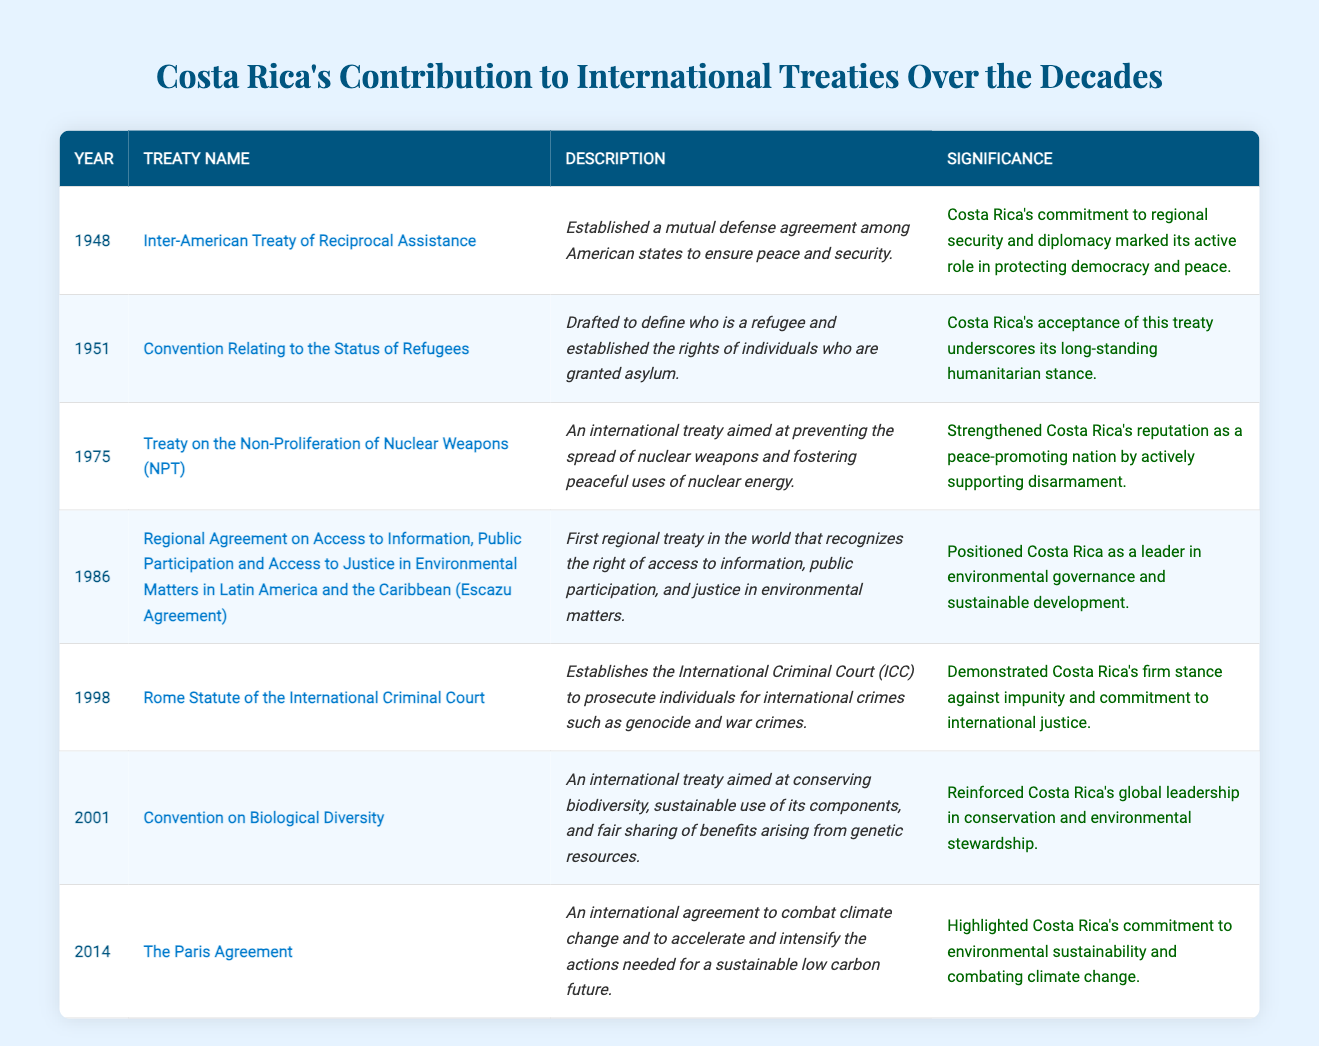What year did Costa Rica sign the Rome Statute of the International Criminal Court? The table lists the year next to the treaty name for the Rome Statute of the International Criminal Court, which is 1998.
Answer: 1998 What treaty was established in 1948? The table shows that in 1948, Costa Rica established the Inter-American Treaty of Reciprocal Assistance.
Answer: Inter-American Treaty of Reciprocal Assistance Which treaty emphasizes Costa Rica's commitment to combating climate change? According to the table, the Paris Agreement, established in 2014, emphasizes Costa Rica's commitment to combating climate change.
Answer: The Paris Agreement How many treaties did Costa Rica sign in the 2000s? According to the table, two treaties were signed in the 2000s: the Convention on Biological Diversity in 2001 and the Paris Agreement in 2014.
Answer: 2 True or False: The Escazu Agreement was the first regional treaty in the world that recognizes the right of access to information in environmental matters. The table confirms that the Escazu Agreement, signed in 1986, is indeed the first regional treaty that recognizes the right of access to information in environmental matters.
Answer: True What is the significance of the Treaty on the Non-Proliferation of Nuclear Weapons for Costa Rica? The table details that the significance of the NPT in 1975 strengthened Costa Rica's reputation as a peace-promoting nation by actively supporting disarmament.
Answer: Strengthened reputation in disarmament List the treaties signed by Costa Rica between 1948 and 1986. By examining the table, the treaties signed by Costa Rica between these years are: Inter-American Treaty of Reciprocal Assistance (1948), Convention Relating to the Status of Refugees (1951), Treaty on the Non-Proliferation of Nuclear Weapons (1975), and the Escazu Agreement (1986).
Answer: 4 treaties Which treaty underscores Costa Rica's role in humanitarian efforts? The Convention Relating to the Status of Refugees, signed in 1951, underscores Costa Rica's long-standing humanitarian stance as mentioned in the table.
Answer: Convention Relating to the Status of Refugees What is the primary focus of the Convention on Biological Diversity? The table describes that the Convention on Biological Diversity aims at conserving biodiversity and the sustainable use of its components.
Answer: Conserving biodiversity In which decade did Costa Rica sign the most treaties listed in the table? The table shows that Costa Rica signed five treaties in the 1990s and 2000s combined (1998 and 2001, with no entries in the 1990s), but the highest is the 2000s, as the last treaty listed is from 2014.
Answer: The 2000s What indicates Costa Rica's environmental leadership according to the data? The table highlights that the Escazu Agreement (1986) and the Convention on Biological Diversity (2001) position Costa Rica as a leader in environmental governance and sustainable development.
Answer: Escazu Agreement and Convention on Biological Diversity 